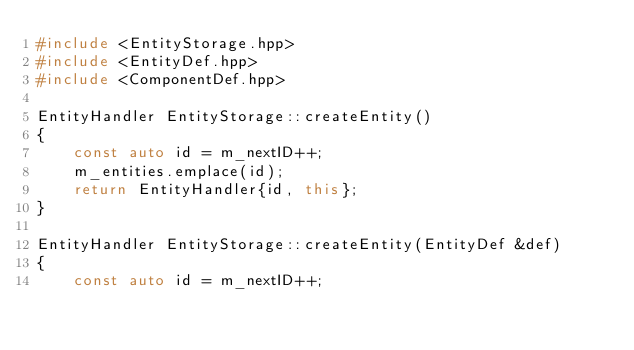<code> <loc_0><loc_0><loc_500><loc_500><_C++_>#include <EntityStorage.hpp>
#include <EntityDef.hpp>
#include <ComponentDef.hpp>

EntityHandler EntityStorage::createEntity()
{
    const auto id = m_nextID++;
    m_entities.emplace(id);
    return EntityHandler{id, this};
}

EntityHandler EntityStorage::createEntity(EntityDef &def)
{
    const auto id = m_nextID++;</code> 